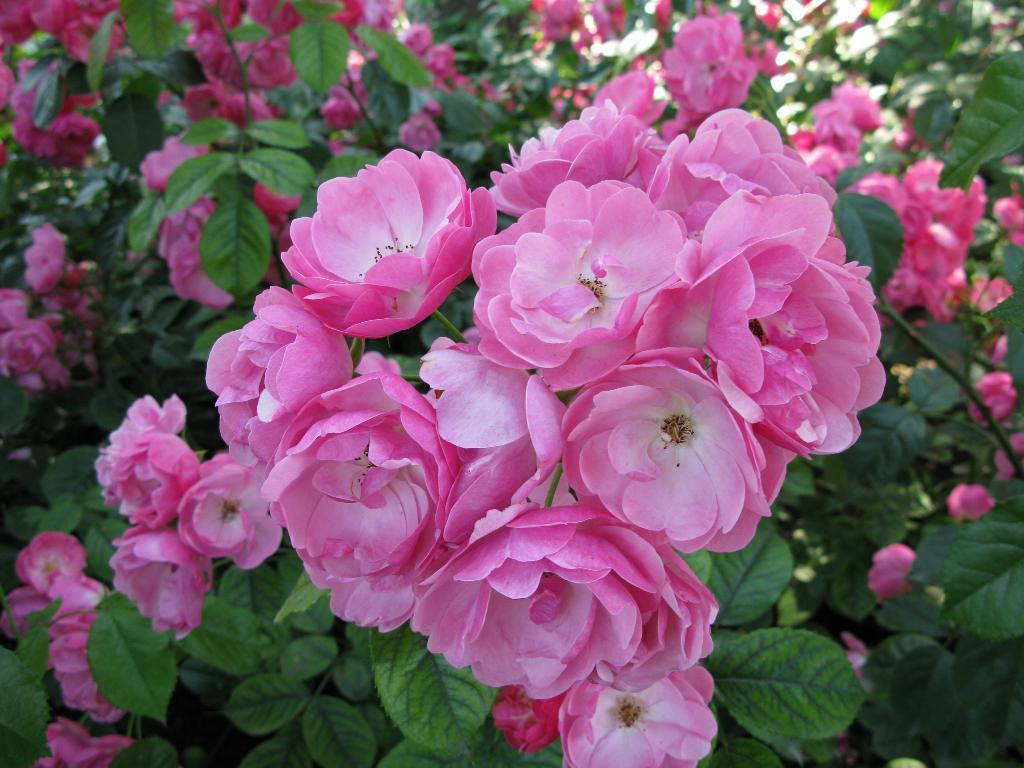Describe this image in one or two sentences. Here we can see a plant with pink flowers. 